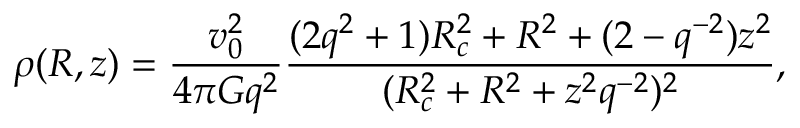Convert formula to latex. <formula><loc_0><loc_0><loc_500><loc_500>\rho ( R , z ) = \frac { v _ { 0 } ^ { 2 } } { 4 \pi G q ^ { 2 } } \frac { ( 2 q ^ { 2 } + 1 ) R _ { c } ^ { 2 } + R ^ { 2 } + ( 2 - q ^ { - 2 } ) z ^ { 2 } } { ( R _ { c } ^ { 2 } + R ^ { 2 } + z ^ { 2 } q ^ { - 2 } ) ^ { 2 } } ,</formula> 